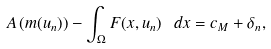Convert formula to latex. <formula><loc_0><loc_0><loc_500><loc_500>A \left ( m ( u _ { n } ) \right ) - \int _ { \Omega } F ( x , u _ { n } ) \ d x = c _ { M } + \delta _ { n } ,</formula> 